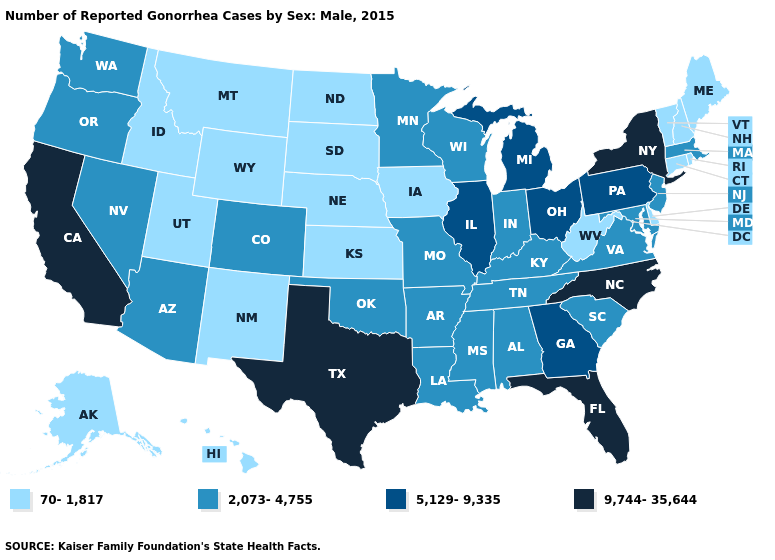Name the states that have a value in the range 5,129-9,335?
Concise answer only. Georgia, Illinois, Michigan, Ohio, Pennsylvania. How many symbols are there in the legend?
Concise answer only. 4. What is the lowest value in the West?
Give a very brief answer. 70-1,817. What is the value of Massachusetts?
Keep it brief. 2,073-4,755. What is the highest value in the USA?
Quick response, please. 9,744-35,644. What is the value of South Carolina?
Write a very short answer. 2,073-4,755. Name the states that have a value in the range 5,129-9,335?
Keep it brief. Georgia, Illinois, Michigan, Ohio, Pennsylvania. Does South Carolina have a lower value than Ohio?
Write a very short answer. Yes. Does New Mexico have the lowest value in the USA?
Concise answer only. Yes. Which states hav the highest value in the MidWest?
Concise answer only. Illinois, Michigan, Ohio. Does Delaware have the lowest value in the South?
Keep it brief. Yes. Does Rhode Island have a lower value than Wyoming?
Keep it brief. No. What is the lowest value in the USA?
Keep it brief. 70-1,817. What is the value of Kansas?
Quick response, please. 70-1,817. Does Nebraska have the lowest value in the MidWest?
Keep it brief. Yes. 